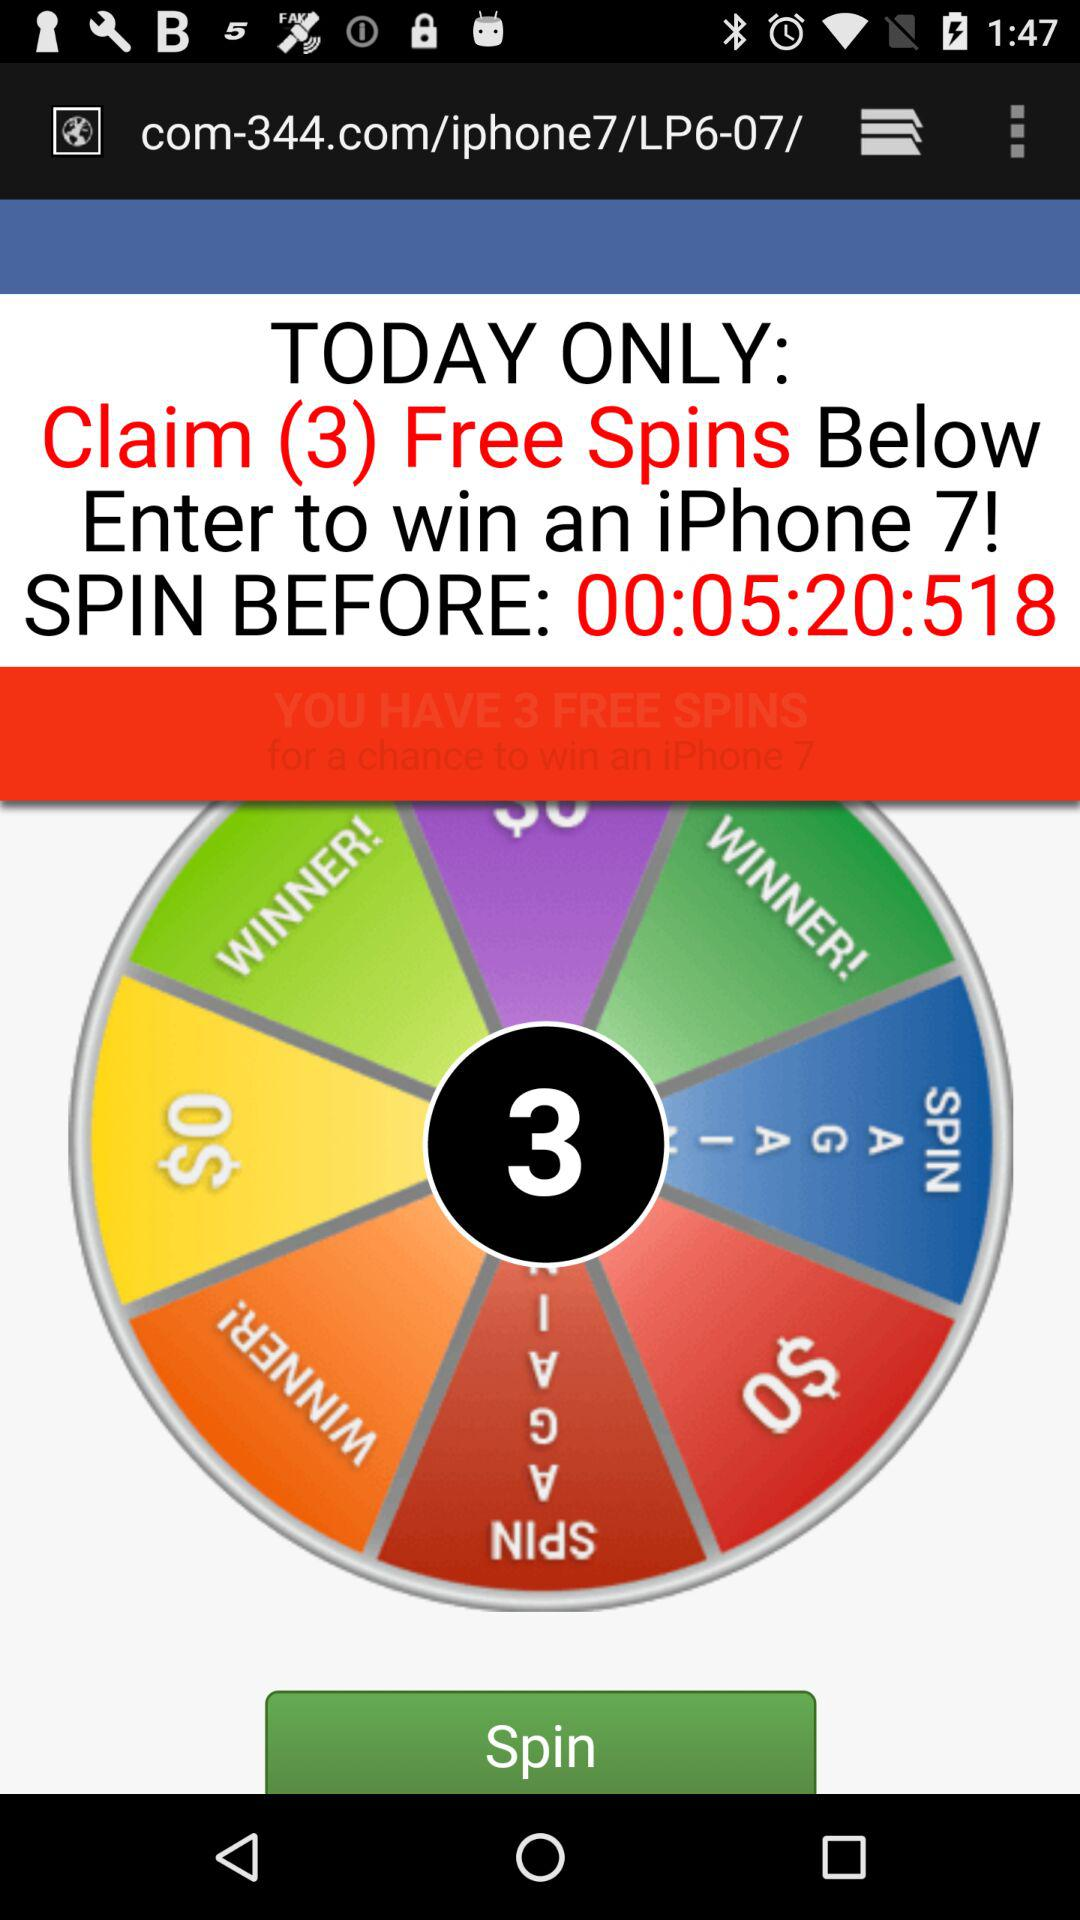Before what time do I have to spin? You have to spin before 5 hours, 20 minutes and 518 seconds. 